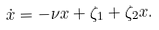Convert formula to latex. <formula><loc_0><loc_0><loc_500><loc_500>\dot { x } = - \nu x + \zeta _ { 1 } + \zeta _ { 2 } x .</formula> 